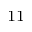<formula> <loc_0><loc_0><loc_500><loc_500>_ { 1 1 }</formula> 